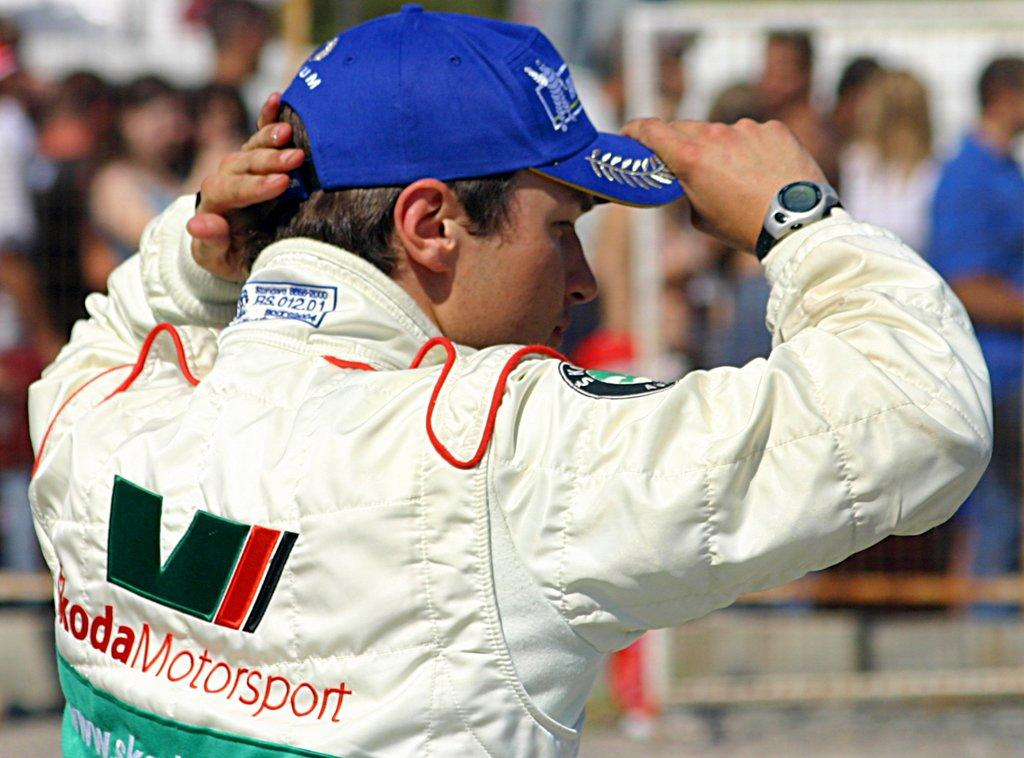<image>
Present a compact description of the photo's key features. A man is wearing a white jacket that says "koda Motorsport" on the back. 